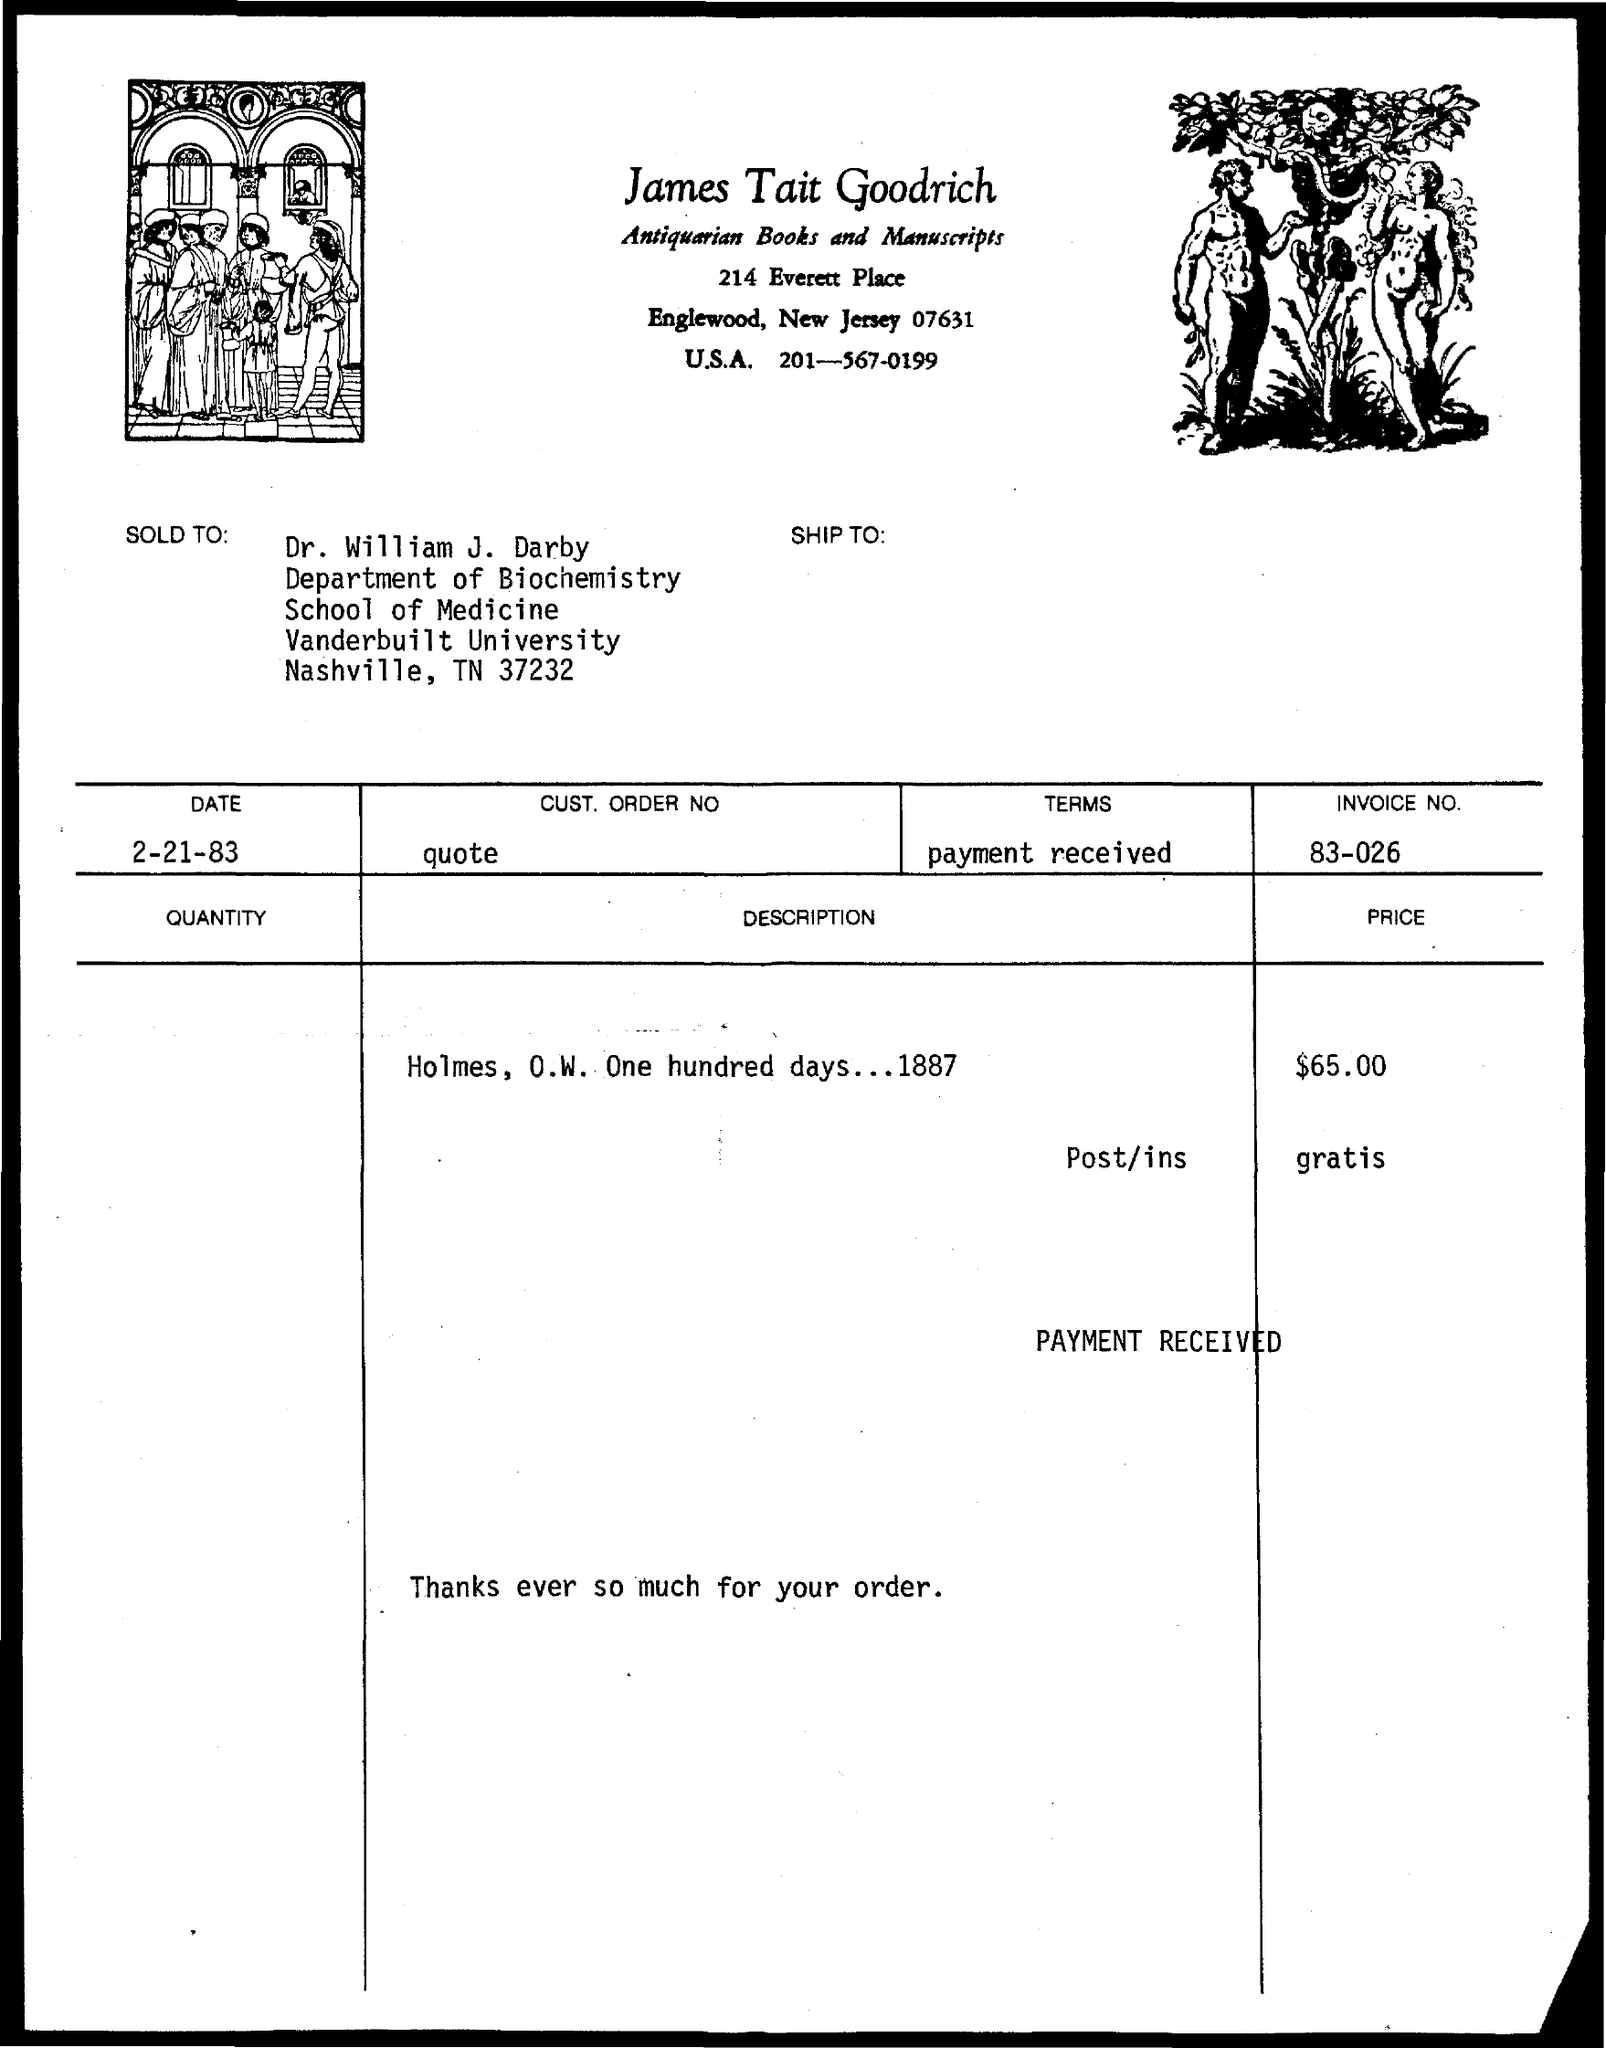Specify some key components in this picture. The invoice number mentioned in the given form is 83-026... . Dr. William J. Darby is a member of Vanderbilt University. The date mentioned in the given form is February 21, 1983. Dr. William J. Darby is affiliated with the Department of Biochemistry. The person to whom the item was sold is Dr. William J. Darby. 